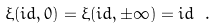Convert formula to latex. <formula><loc_0><loc_0><loc_500><loc_500>\xi ( i d , 0 ) = \xi ( i d , \pm \infty ) = i d \ .</formula> 